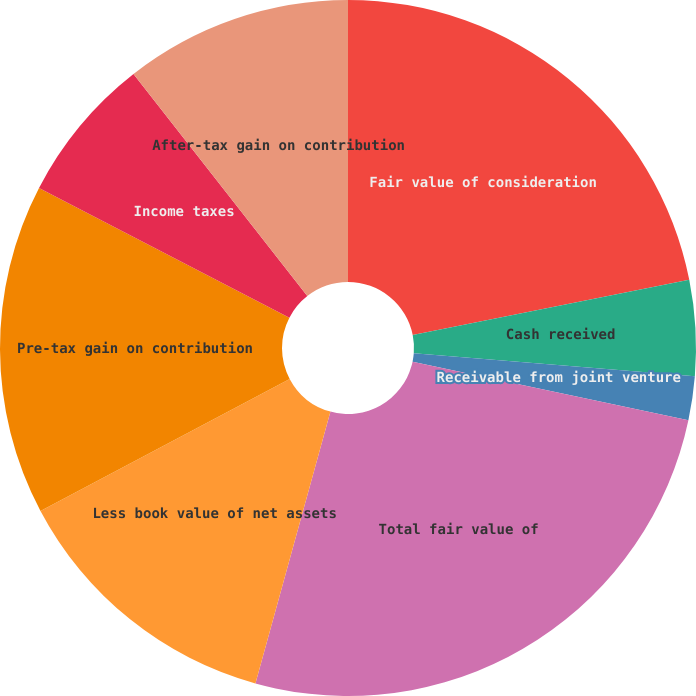<chart> <loc_0><loc_0><loc_500><loc_500><pie_chart><fcel>Fair value of consideration<fcel>Cash received<fcel>Receivable from joint venture<fcel>Total fair value of<fcel>Less book value of net assets<fcel>Pre-tax gain on contribution<fcel>Income taxes<fcel>After-tax gain on contribution<nl><fcel>21.86%<fcel>4.43%<fcel>2.04%<fcel>25.95%<fcel>12.96%<fcel>15.36%<fcel>6.82%<fcel>10.57%<nl></chart> 